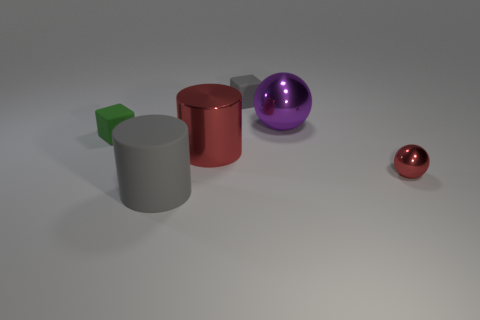How big is the gray rubber object that is behind the big shiny thing behind the big metallic thing that is on the left side of the purple ball?
Offer a very short reply. Small. There is a purple ball that is the same size as the red cylinder; what material is it?
Offer a very short reply. Metal. Is there another green rubber cube that has the same size as the green matte cube?
Provide a succinct answer. No. Is the large matte thing the same shape as the big red object?
Your response must be concise. Yes. There is a tiny object to the left of the big gray thing that is in front of the big purple metal sphere; are there any big red metal cylinders to the left of it?
Your answer should be compact. No. How many other objects are the same color as the big metal sphere?
Your answer should be compact. 0. Do the red shiny object right of the red cylinder and the thing in front of the small metallic thing have the same size?
Offer a very short reply. No. Are there the same number of green cubes that are left of the tiny green matte block and small green rubber cubes that are left of the large red cylinder?
Provide a short and direct response. No. There is a purple metal ball; is its size the same as the gray thing behind the green matte block?
Provide a succinct answer. No. There is a cube that is in front of the gray rubber thing behind the big red cylinder; what is its material?
Provide a succinct answer. Rubber. 